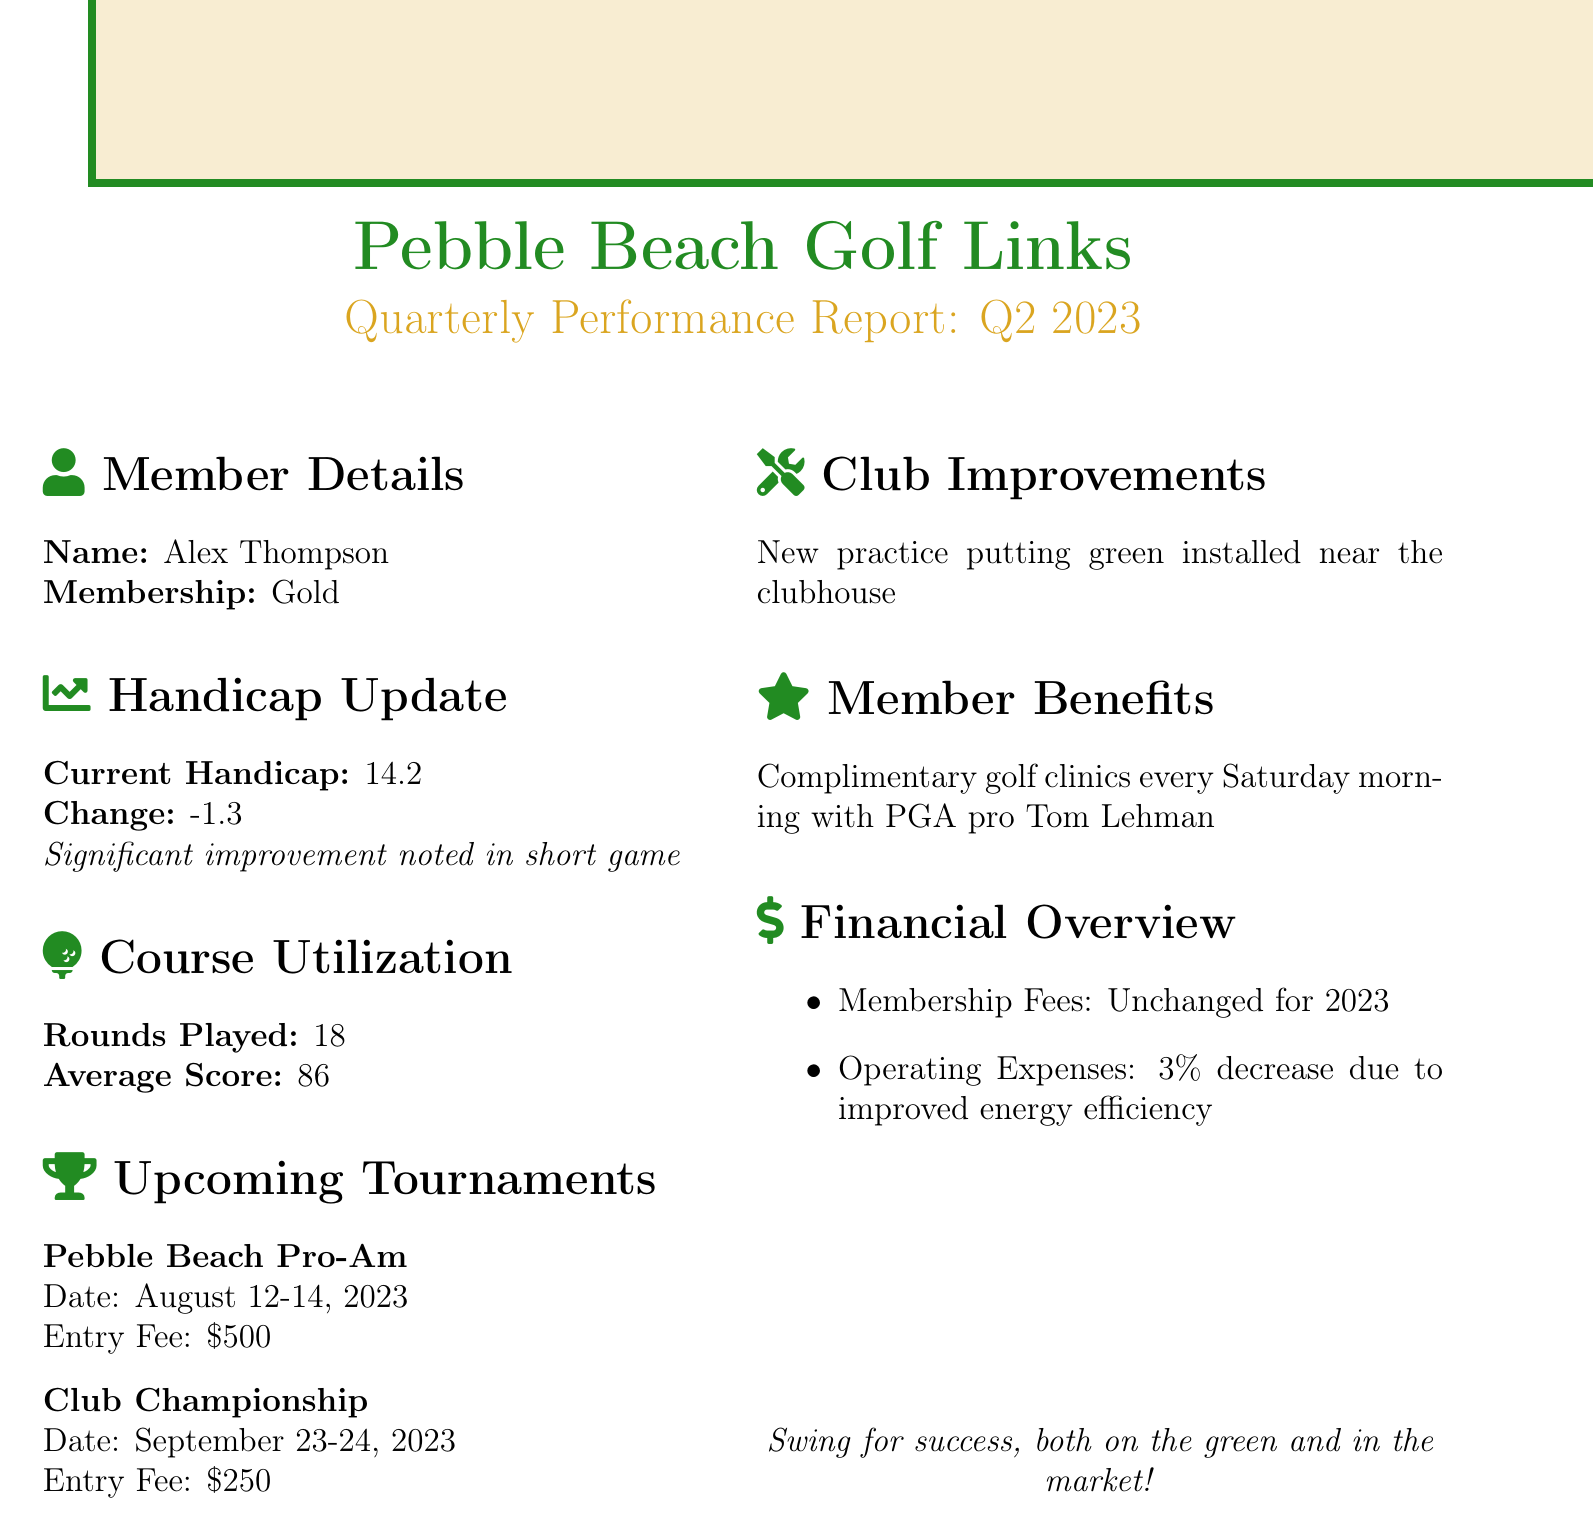What is the club name? The club name is explicitly stated in the report's header.
Answer: Pebble Beach Golf Links What is the reporting period for this performance report? The reporting period is indicated in the title of the document.
Answer: Q2 2023 What is Alex Thompson's current handicap? The current handicap is found in the handicap update section of the document.
Answer: 14.2 What significant improvement was noted in the handicap update? The comment in the handicap update provides insight into the improvements.
Answer: Significant improvement noted in short game How many rounds did Alex play this quarter? The number of rounds played is noted in the course utilization section.
Answer: 18 What is the date for the Pebble Beach Pro-Am tournament? The tournament date is clearly listed under upcoming tournaments.
Answer: August 12-14, 2023 What is the entry fee for the Club Championship? This information is provided in the tournament details section.
Answer: $250 What was the percentage decrease in operating expenses? The section on financial overview mentions this decrease.
Answer: 3% What new improvement has been installed at the club? The club improvements section details the new addition.
Answer: New practice putting green installed near the clubhouse What benefit is offered to members every Saturday morning? The member benefits section provides this information.
Answer: Complimentary golf clinics with PGA pro Tom Lehman 